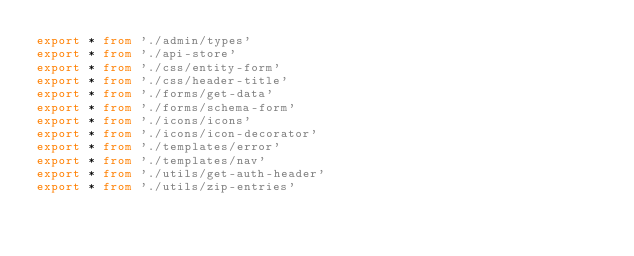Convert code to text. <code><loc_0><loc_0><loc_500><loc_500><_TypeScript_>export * from './admin/types'
export * from './api-store'
export * from './css/entity-form'
export * from './css/header-title'
export * from './forms/get-data'
export * from './forms/schema-form'
export * from './icons/icons'
export * from './icons/icon-decorator'
export * from './templates/error'
export * from './templates/nav'
export * from './utils/get-auth-header'
export * from './utils/zip-entries'
</code> 